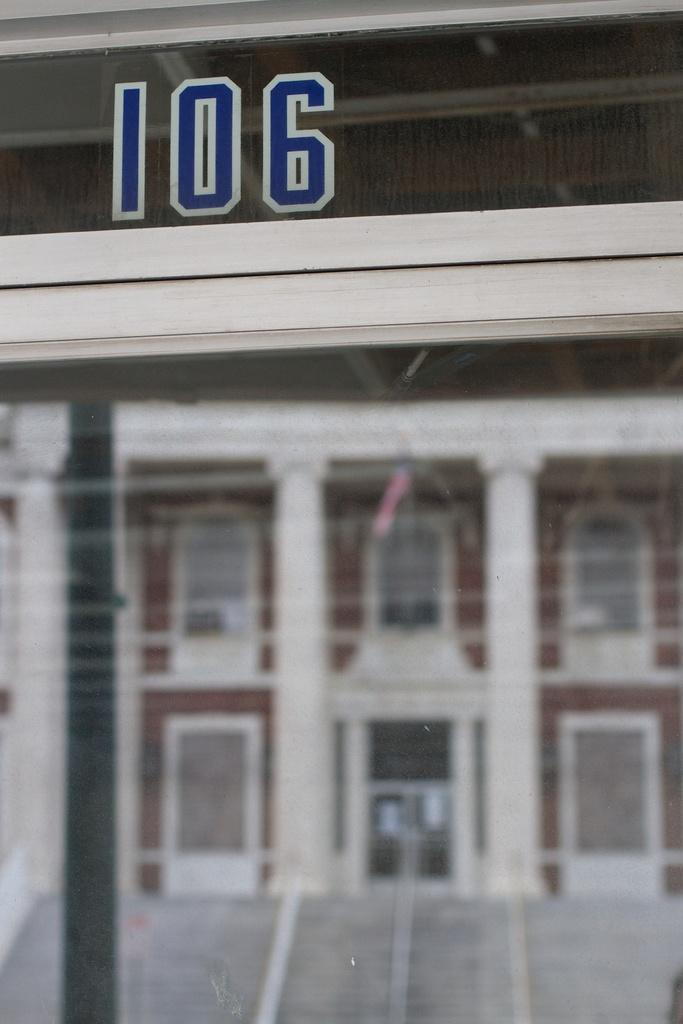<image>
Present a compact description of the photo's key features. a building with the number 106 at the top 